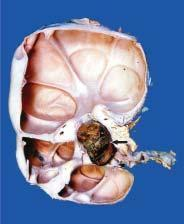what is the cystic change seen to extend into?
Answer the question using a single word or phrase. Renal p arenchyma 